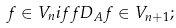<formula> <loc_0><loc_0><loc_500><loc_500>f \in V _ { n } i f f D _ { A } f \in V _ { n + 1 } ;</formula> 